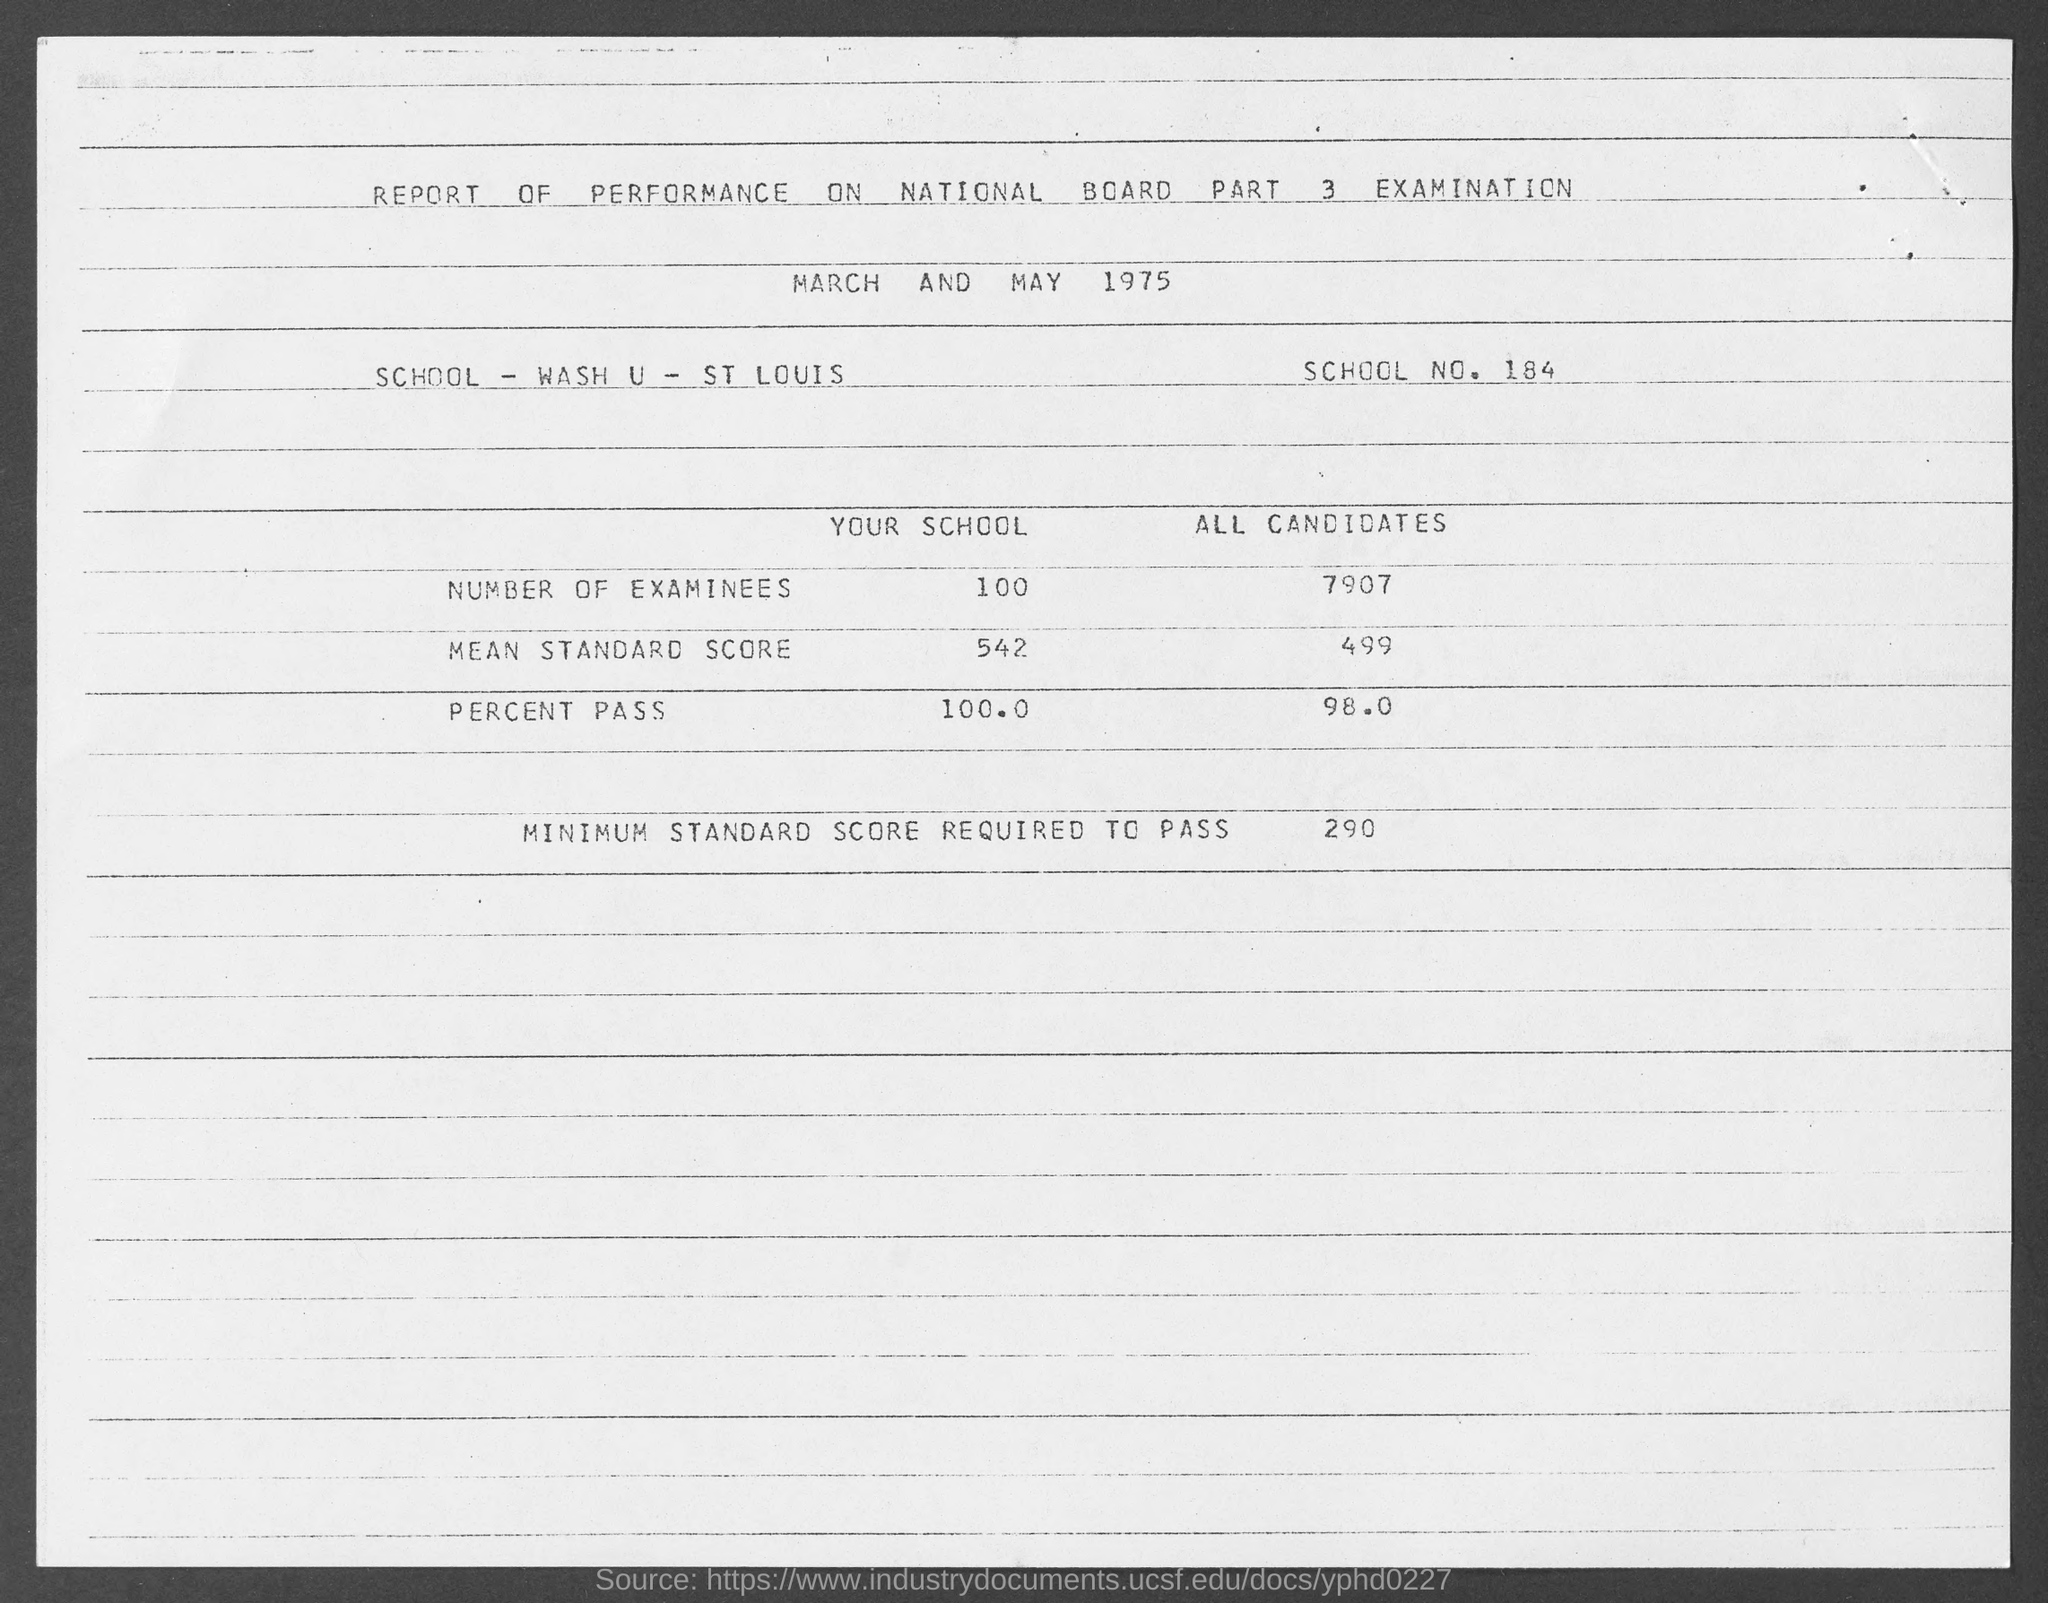What is the document title?
Provide a succinct answer. REPORT OF PERFORMANCE ON NATIONAL BOARD PART 3 EXAMINATION. When are the exams scheduled?
Make the answer very short. MARCH AND MAY 1975. Which school is mentioned?
Keep it short and to the point. WASH U - ST LOUIS. What is the school number?
Offer a terse response. 184. What is the minimum standard score required to pass?
Offer a very short reply. 290. What is the PERCENT PASS of all candidates?
Offer a terse response. 98.0. 